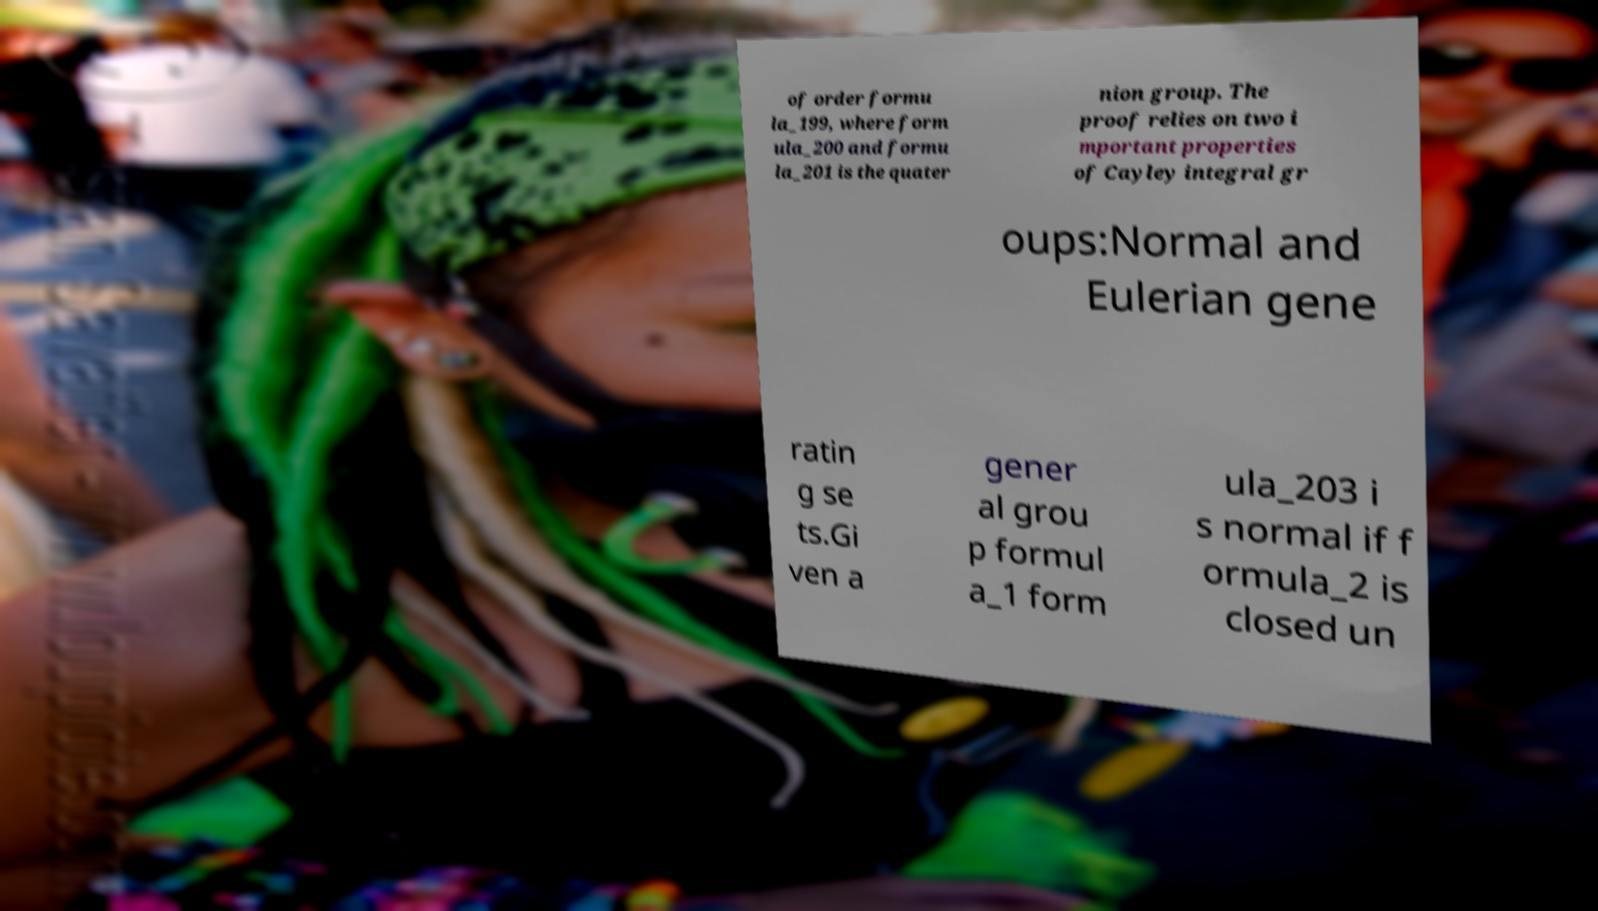Can you read and provide the text displayed in the image?This photo seems to have some interesting text. Can you extract and type it out for me? of order formu la_199, where form ula_200 and formu la_201 is the quater nion group. The proof relies on two i mportant properties of Cayley integral gr oups:Normal and Eulerian gene ratin g se ts.Gi ven a gener al grou p formul a_1 form ula_203 i s normal if f ormula_2 is closed un 